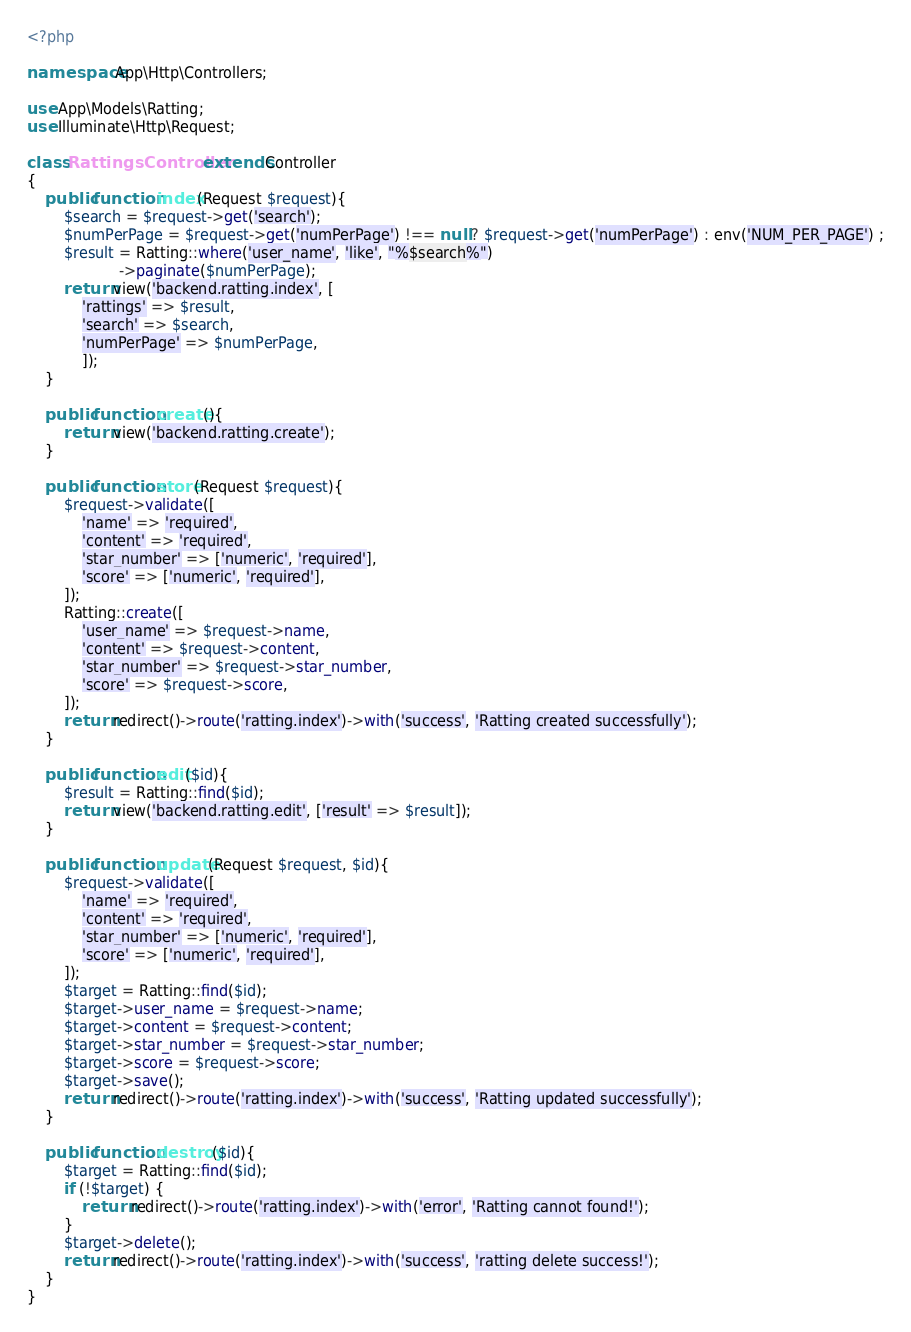<code> <loc_0><loc_0><loc_500><loc_500><_PHP_><?php

namespace App\Http\Controllers;

use App\Models\Ratting;
use Illuminate\Http\Request;

class RattingsController extends Controller
{
    public function index(Request $request){
        $search = $request->get('search');
        $numPerPage = $request->get('numPerPage') !== null ? $request->get('numPerPage') : env('NUM_PER_PAGE') ;
        $result = Ratting::where('user_name', 'like', "%$search%")
                    ->paginate($numPerPage);
        return view('backend.ratting.index', [
            'rattings' => $result,
            'search' => $search,
            'numPerPage' => $numPerPage,
            ]);
    }

    public function create(){
        return view('backend.ratting.create');
    }

    public function store(Request $request){
        $request->validate([
            'name' => 'required',
            'content' => 'required',
            'star_number' => ['numeric', 'required'],
            'score' => ['numeric', 'required'],
        ]);
        Ratting::create([
            'user_name' => $request->name,
            'content' => $request->content,
            'star_number' => $request->star_number,
            'score' => $request->score,
        ]);
        return redirect()->route('ratting.index')->with('success', 'Ratting created successfully');
    }

    public function edit($id){
        $result = Ratting::find($id);
        return view('backend.ratting.edit', ['result' => $result]);
    }

    public function update(Request $request, $id){
        $request->validate([
            'name' => 'required',
            'content' => 'required',
            'star_number' => ['numeric', 'required'],
            'score' => ['numeric', 'required'],
        ]);
        $target = Ratting::find($id);
        $target->user_name = $request->name;
        $target->content = $request->content;
        $target->star_number = $request->star_number;
        $target->score = $request->score;
        $target->save();
        return redirect()->route('ratting.index')->with('success', 'Ratting updated successfully');
    }

    public function destroy($id){
        $target = Ratting::find($id);
        if (!$target) {
            return redirect()->route('ratting.index')->with('error', 'Ratting cannot found!');
        }
        $target->delete(); 
        return redirect()->route('ratting.index')->with('success', 'ratting delete success!');
    }
}
</code> 